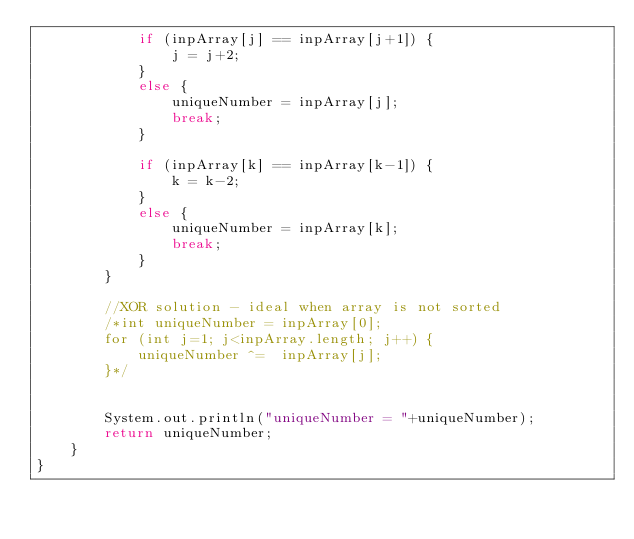Convert code to text. <code><loc_0><loc_0><loc_500><loc_500><_Java_>			if (inpArray[j] == inpArray[j+1]) {
				j = j+2;
			}
			else {
				uniqueNumber = inpArray[j];
				break;
			}

			if (inpArray[k] == inpArray[k-1]) {
				k = k-2;
			}
			else {
				uniqueNumber = inpArray[k];
				break;
			}
		}

		//XOR solution - ideal when array is not sorted
		/*int uniqueNumber = inpArray[0];
		for (int j=1; j<inpArray.length; j++) {
			uniqueNumber ^=  inpArray[j];
		}*/
	
		
		System.out.println("uniqueNumber = "+uniqueNumber);
		return uniqueNumber;
	}
}</code> 